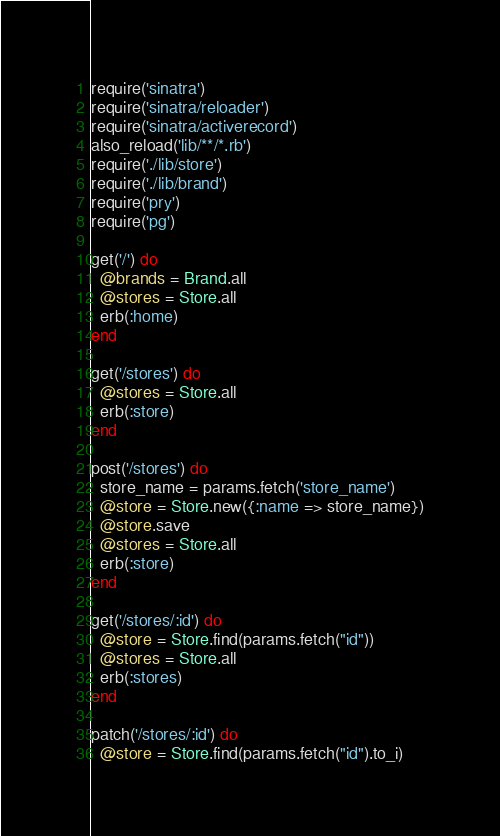<code> <loc_0><loc_0><loc_500><loc_500><_Ruby_>require('sinatra')
require('sinatra/reloader')
require('sinatra/activerecord')
also_reload('lib/**/*.rb')
require('./lib/store')
require('./lib/brand')
require('pry')
require('pg')

get('/') do
  @brands = Brand.all
  @stores = Store.all
  erb(:home)
end

get('/stores') do
  @stores = Store.all
  erb(:store)
end

post('/stores') do
  store_name = params.fetch('store_name')
  @store = Store.new({:name => store_name})
  @store.save
  @stores = Store.all
  erb(:store)
end

get('/stores/:id') do
  @store = Store.find(params.fetch("id"))
  @stores = Store.all
  erb(:stores)
end

patch('/stores/:id') do
  @store = Store.find(params.fetch("id").to_i)</code> 